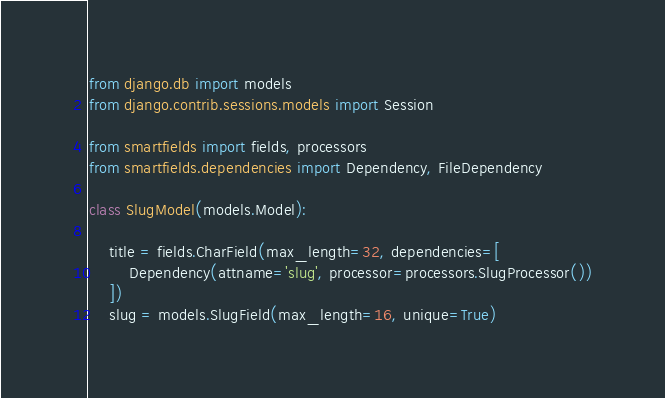Convert code to text. <code><loc_0><loc_0><loc_500><loc_500><_Python_>from django.db import models
from django.contrib.sessions.models import Session

from smartfields import fields, processors
from smartfields.dependencies import Dependency, FileDependency

class SlugModel(models.Model):

    title = fields.CharField(max_length=32, dependencies=[
        Dependency(attname='slug', processor=processors.SlugProcessor())
    ])
    slug = models.SlugField(max_length=16, unique=True)
</code> 